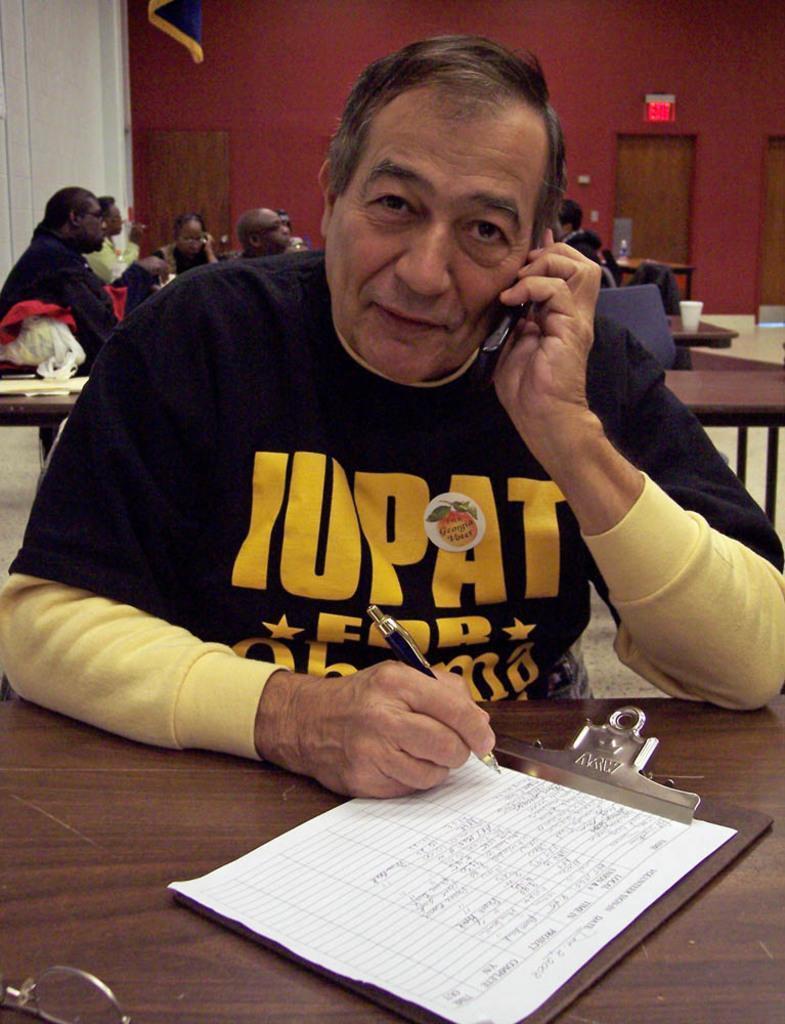In one or two sentences, can you explain what this image depicts? In this image, I can see a person sitting and holding a mobile and a pen. In front of the person, I can see a paper to a clipboard, which is on a table. Behind the man, I can see a group of people sitting and there are tables, a cup, bag and few other objects. In the background there are doors and an exit board to the wall. At the top of the image, I can see a cloth. 